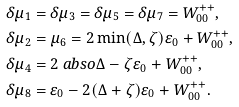Convert formula to latex. <formula><loc_0><loc_0><loc_500><loc_500>\delta \mu _ { 1 } & = \delta \mu _ { 3 } = \delta \mu _ { 5 } = \delta \mu _ { 7 } = W ^ { + + } _ { 0 0 } , \\ \delta \mu _ { 2 } & = \mu _ { 6 } = 2 \min ( \Delta , \zeta ) \varepsilon _ { 0 } + W ^ { + + } _ { 0 0 } , \\ \delta \mu _ { 4 } & = 2 \ a b s o { \Delta - \zeta } \varepsilon _ { 0 } + W ^ { + + } _ { 0 0 } , \\ \delta \mu _ { 8 } & = \varepsilon _ { 0 } - 2 ( \Delta + \zeta ) \varepsilon _ { 0 } + W ^ { + + } _ { 0 0 } .</formula> 